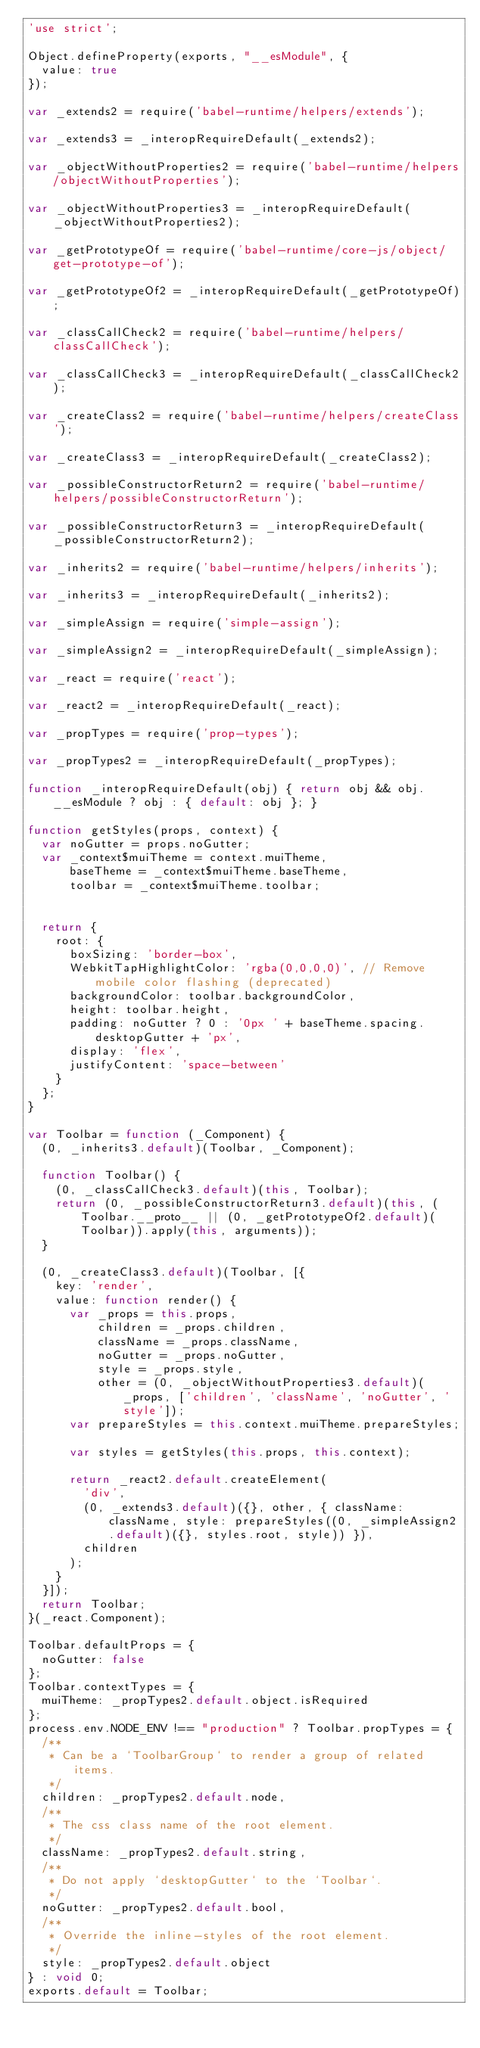Convert code to text. <code><loc_0><loc_0><loc_500><loc_500><_JavaScript_>'use strict';

Object.defineProperty(exports, "__esModule", {
  value: true
});

var _extends2 = require('babel-runtime/helpers/extends');

var _extends3 = _interopRequireDefault(_extends2);

var _objectWithoutProperties2 = require('babel-runtime/helpers/objectWithoutProperties');

var _objectWithoutProperties3 = _interopRequireDefault(_objectWithoutProperties2);

var _getPrototypeOf = require('babel-runtime/core-js/object/get-prototype-of');

var _getPrototypeOf2 = _interopRequireDefault(_getPrototypeOf);

var _classCallCheck2 = require('babel-runtime/helpers/classCallCheck');

var _classCallCheck3 = _interopRequireDefault(_classCallCheck2);

var _createClass2 = require('babel-runtime/helpers/createClass');

var _createClass3 = _interopRequireDefault(_createClass2);

var _possibleConstructorReturn2 = require('babel-runtime/helpers/possibleConstructorReturn');

var _possibleConstructorReturn3 = _interopRequireDefault(_possibleConstructorReturn2);

var _inherits2 = require('babel-runtime/helpers/inherits');

var _inherits3 = _interopRequireDefault(_inherits2);

var _simpleAssign = require('simple-assign');

var _simpleAssign2 = _interopRequireDefault(_simpleAssign);

var _react = require('react');

var _react2 = _interopRequireDefault(_react);

var _propTypes = require('prop-types');

var _propTypes2 = _interopRequireDefault(_propTypes);

function _interopRequireDefault(obj) { return obj && obj.__esModule ? obj : { default: obj }; }

function getStyles(props, context) {
  var noGutter = props.noGutter;
  var _context$muiTheme = context.muiTheme,
      baseTheme = _context$muiTheme.baseTheme,
      toolbar = _context$muiTheme.toolbar;


  return {
    root: {
      boxSizing: 'border-box',
      WebkitTapHighlightColor: 'rgba(0,0,0,0)', // Remove mobile color flashing (deprecated)
      backgroundColor: toolbar.backgroundColor,
      height: toolbar.height,
      padding: noGutter ? 0 : '0px ' + baseTheme.spacing.desktopGutter + 'px',
      display: 'flex',
      justifyContent: 'space-between'
    }
  };
}

var Toolbar = function (_Component) {
  (0, _inherits3.default)(Toolbar, _Component);

  function Toolbar() {
    (0, _classCallCheck3.default)(this, Toolbar);
    return (0, _possibleConstructorReturn3.default)(this, (Toolbar.__proto__ || (0, _getPrototypeOf2.default)(Toolbar)).apply(this, arguments));
  }

  (0, _createClass3.default)(Toolbar, [{
    key: 'render',
    value: function render() {
      var _props = this.props,
          children = _props.children,
          className = _props.className,
          noGutter = _props.noGutter,
          style = _props.style,
          other = (0, _objectWithoutProperties3.default)(_props, ['children', 'className', 'noGutter', 'style']);
      var prepareStyles = this.context.muiTheme.prepareStyles;

      var styles = getStyles(this.props, this.context);

      return _react2.default.createElement(
        'div',
        (0, _extends3.default)({}, other, { className: className, style: prepareStyles((0, _simpleAssign2.default)({}, styles.root, style)) }),
        children
      );
    }
  }]);
  return Toolbar;
}(_react.Component);

Toolbar.defaultProps = {
  noGutter: false
};
Toolbar.contextTypes = {
  muiTheme: _propTypes2.default.object.isRequired
};
process.env.NODE_ENV !== "production" ? Toolbar.propTypes = {
  /**
   * Can be a `ToolbarGroup` to render a group of related items.
   */
  children: _propTypes2.default.node,
  /**
   * The css class name of the root element.
   */
  className: _propTypes2.default.string,
  /**
   * Do not apply `desktopGutter` to the `Toolbar`.
   */
  noGutter: _propTypes2.default.bool,
  /**
   * Override the inline-styles of the root element.
   */
  style: _propTypes2.default.object
} : void 0;
exports.default = Toolbar;</code> 